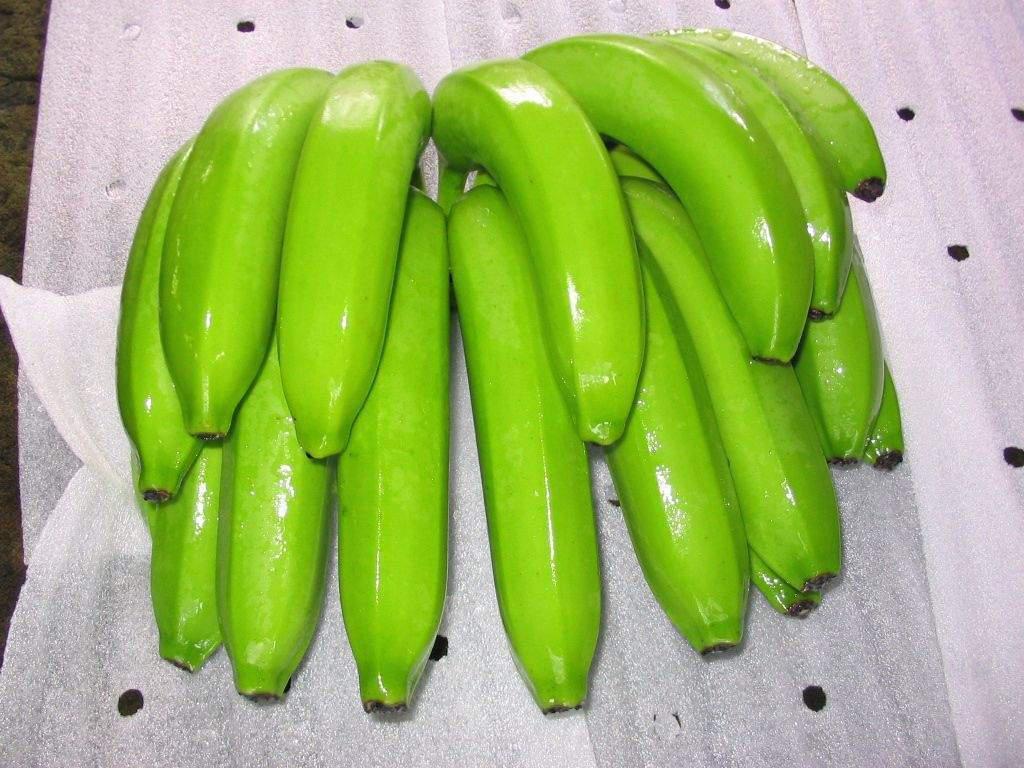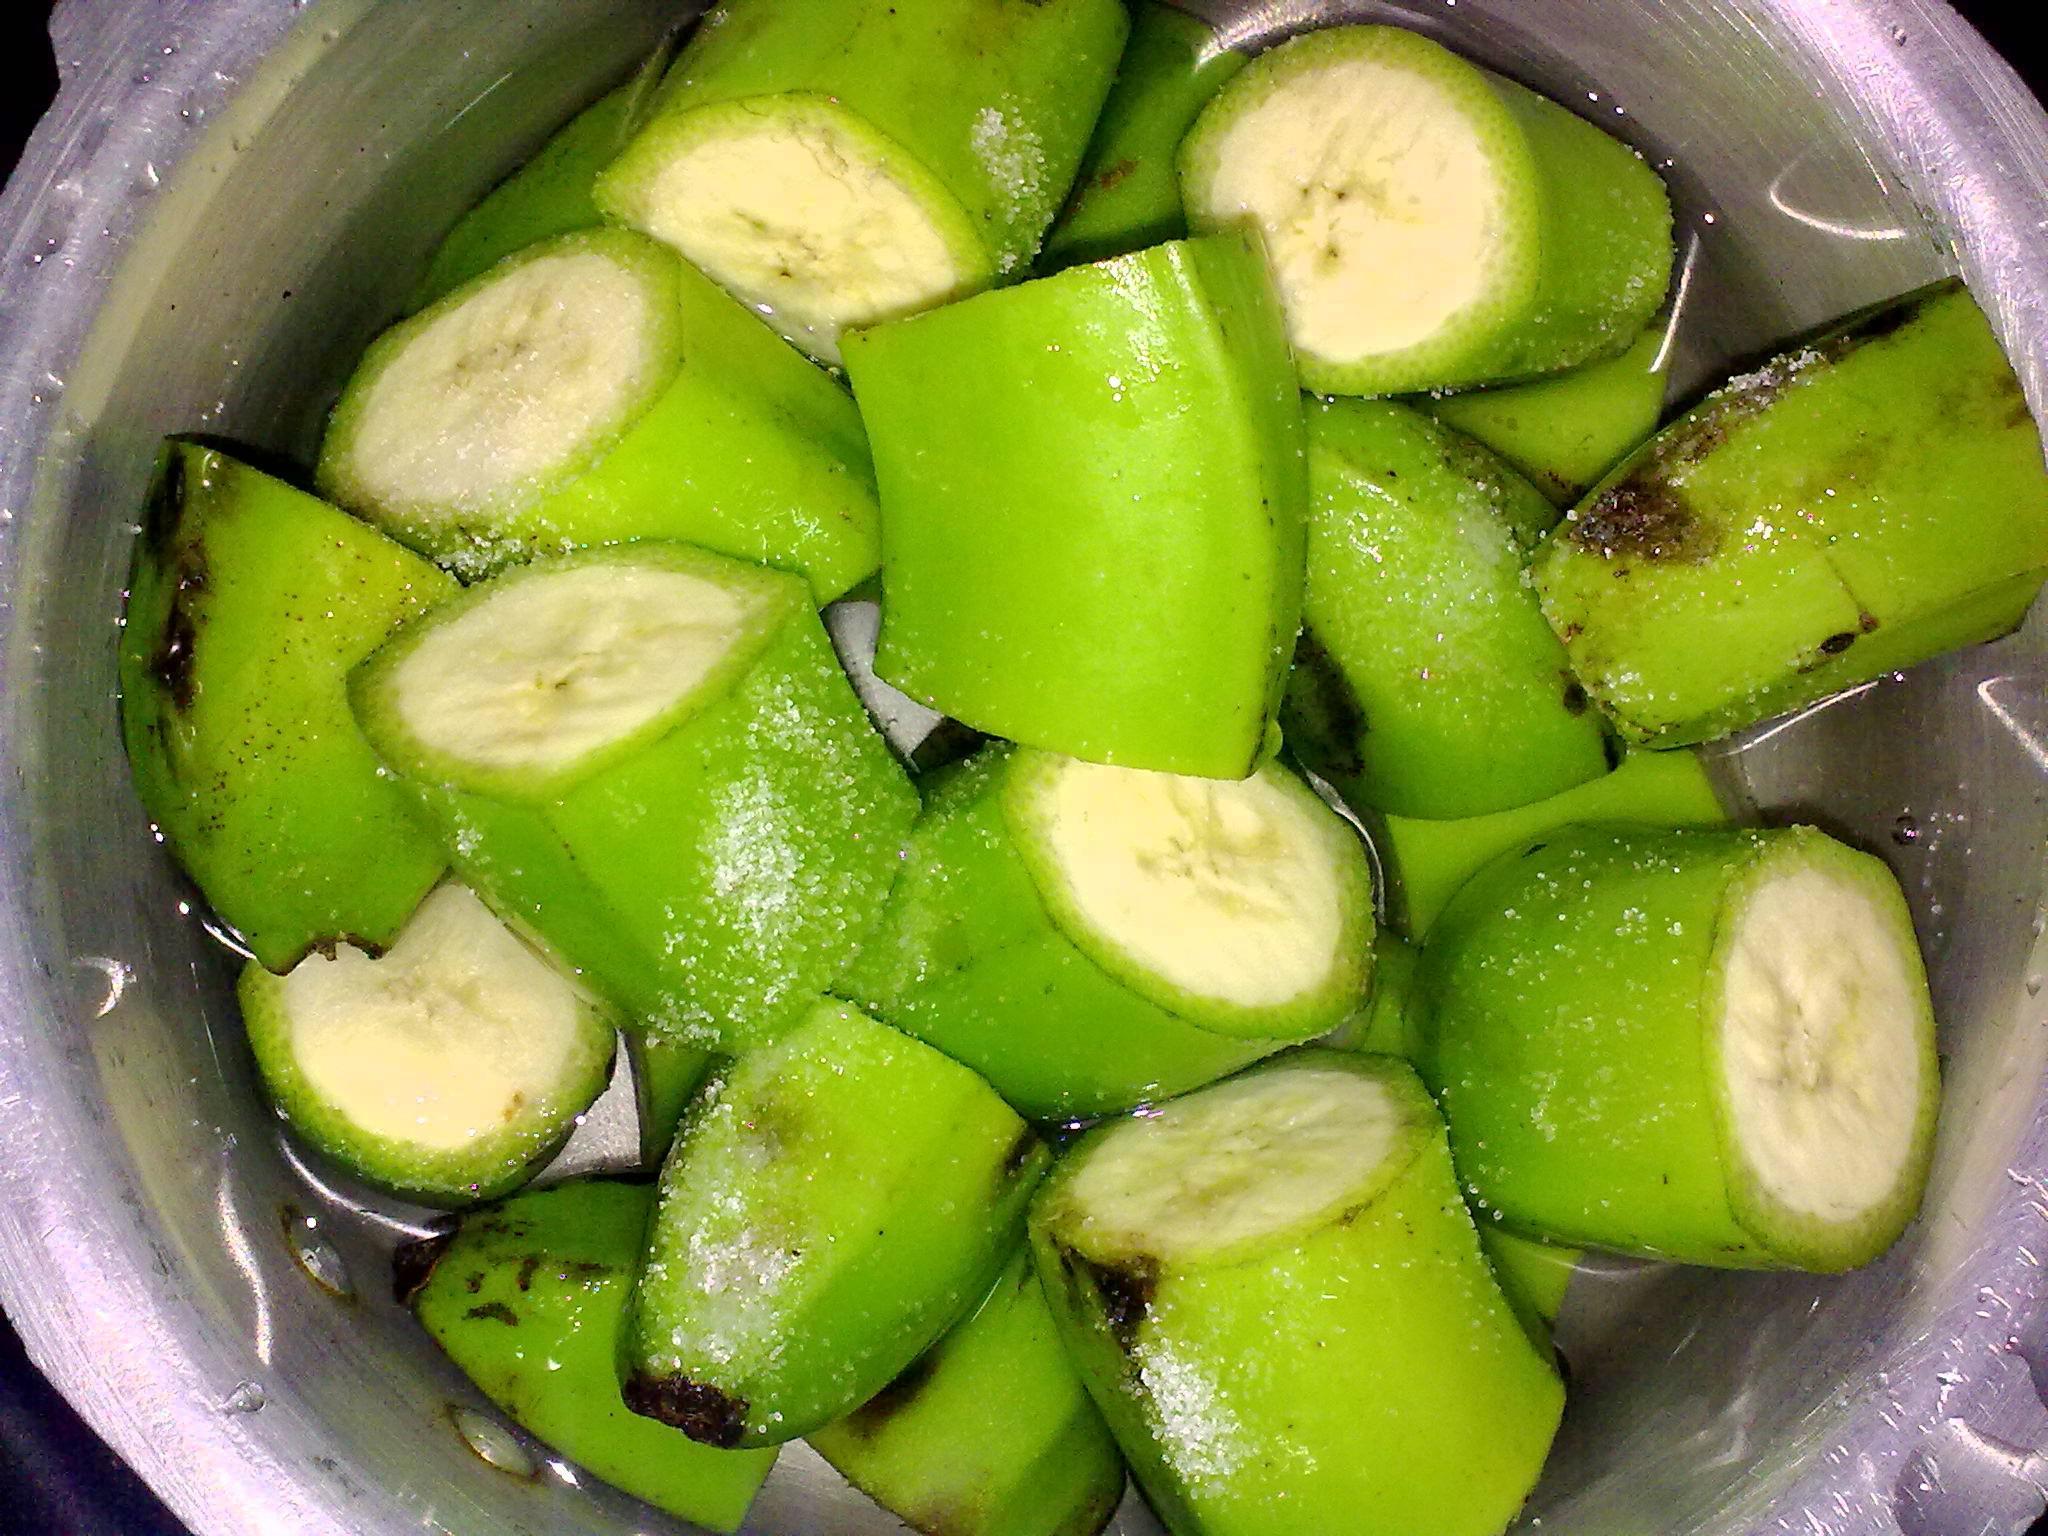The first image is the image on the left, the second image is the image on the right. Analyze the images presented: Is the assertion "One image includes only one small bunch of green bananas, with no more than five bananas visible." valid? Answer yes or no. No. The first image is the image on the left, the second image is the image on the right. Considering the images on both sides, is "There is an image with one bunch of unripe bananas, and another image with multiple bunches." valid? Answer yes or no. No. 